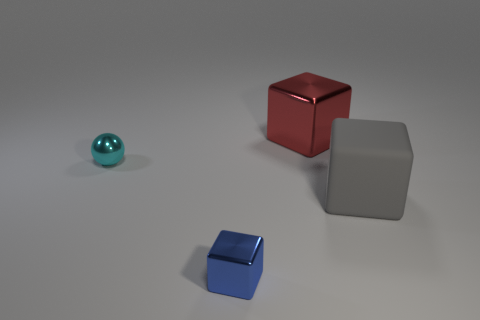Subtract all metal cubes. How many cubes are left? 1 Subtract all red blocks. How many blocks are left? 2 Subtract all yellow spheres. How many yellow blocks are left? 0 Add 2 red blocks. How many objects exist? 6 Subtract 1 spheres. How many spheres are left? 0 Subtract all blue balls. Subtract all yellow cylinders. How many balls are left? 1 Subtract all large yellow metal cubes. Subtract all tiny objects. How many objects are left? 2 Add 1 metal objects. How many metal objects are left? 4 Add 2 big gray rubber cubes. How many big gray rubber cubes exist? 3 Subtract 1 cyan spheres. How many objects are left? 3 